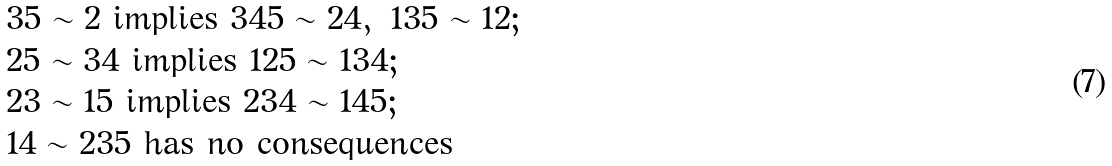<formula> <loc_0><loc_0><loc_500><loc_500>& 3 5 \sim 2 \ \text {implies} \ 3 4 5 \sim 2 4 , \ 1 3 5 \sim 1 2 ; \\ & 2 5 \sim 3 4 \ \text {implies} \ 1 2 5 \sim 1 3 4 ; \\ & 2 3 \sim 1 5 \ \text {implies} \ 2 3 4 \sim 1 4 5 ; \\ & 1 4 \sim 2 3 5 \ \text {has no consequences}</formula> 